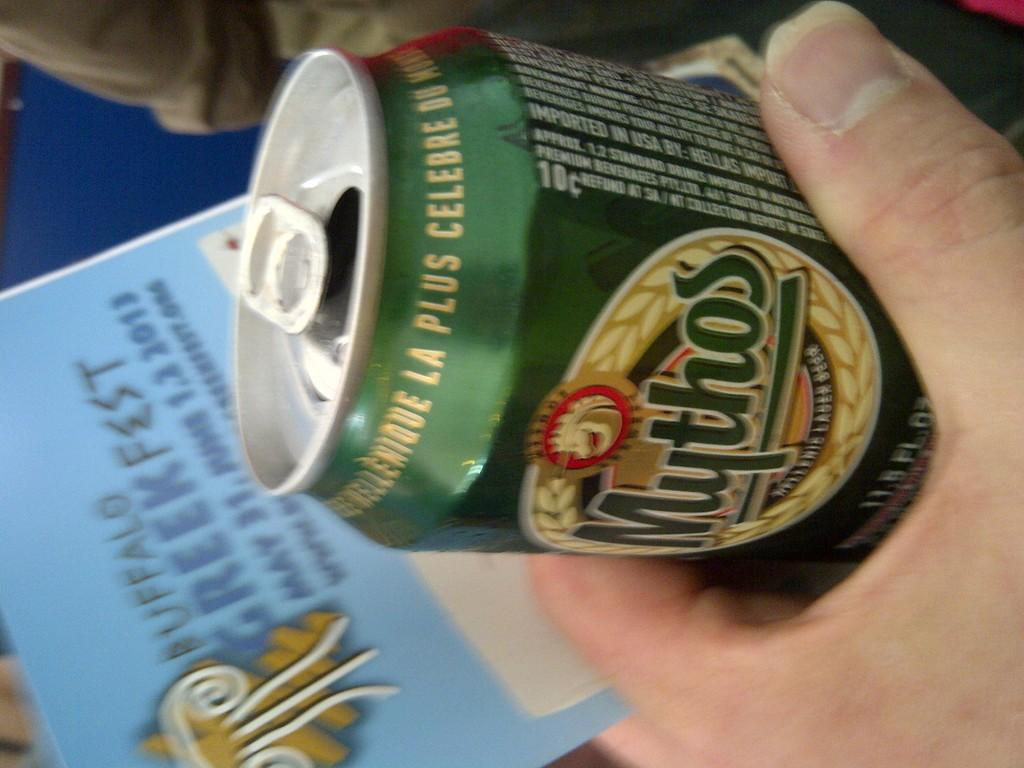<image>
Render a clear and concise summary of the photo. hand clucthes a Mythos Greek beer can just above a flyer for A Greek fest just below 